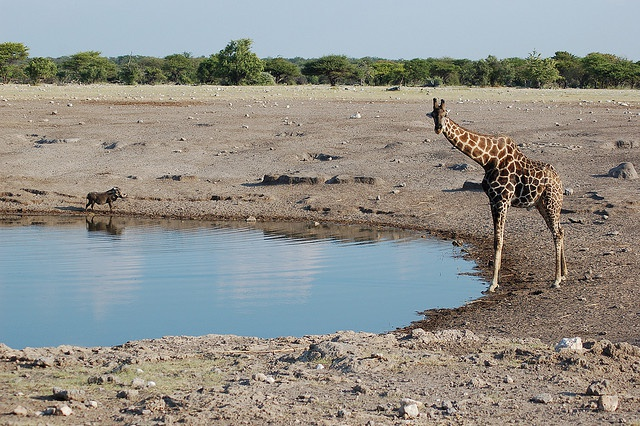Describe the objects in this image and their specific colors. I can see a giraffe in lightblue, black, maroon, and gray tones in this image. 